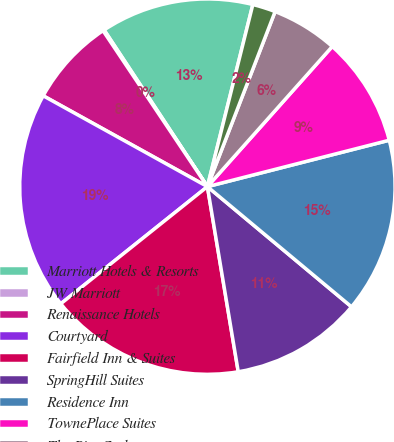Convert chart. <chart><loc_0><loc_0><loc_500><loc_500><pie_chart><fcel>Marriott Hotels & Resorts<fcel>JW Marriott<fcel>Renaissance Hotels<fcel>Courtyard<fcel>Fairfield Inn & Suites<fcel>SpringHill Suites<fcel>Residence Inn<fcel>TownePlace Suites<fcel>The Ritz-Carlton<fcel>The Ritz-Carlton-Residential<nl><fcel>13.17%<fcel>0.11%<fcel>7.57%<fcel>18.77%<fcel>16.9%<fcel>11.31%<fcel>15.04%<fcel>9.44%<fcel>5.71%<fcel>1.98%<nl></chart> 